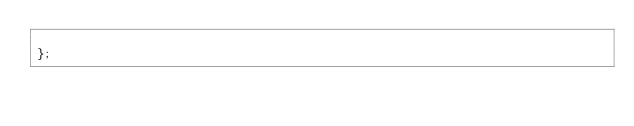Convert code to text. <code><loc_0><loc_0><loc_500><loc_500><_TypeScript_>
};</code> 